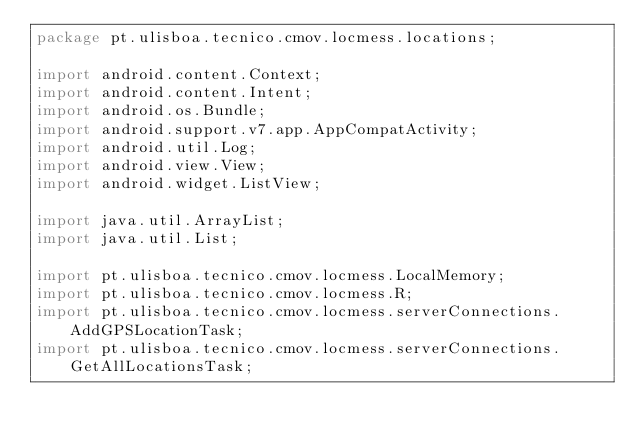Convert code to text. <code><loc_0><loc_0><loc_500><loc_500><_Java_>package pt.ulisboa.tecnico.cmov.locmess.locations;

import android.content.Context;
import android.content.Intent;
import android.os.Bundle;
import android.support.v7.app.AppCompatActivity;
import android.util.Log;
import android.view.View;
import android.widget.ListView;

import java.util.ArrayList;
import java.util.List;

import pt.ulisboa.tecnico.cmov.locmess.LocalMemory;
import pt.ulisboa.tecnico.cmov.locmess.R;
import pt.ulisboa.tecnico.cmov.locmess.serverConnections.AddGPSLocationTask;
import pt.ulisboa.tecnico.cmov.locmess.serverConnections.GetAllLocationsTask;</code> 